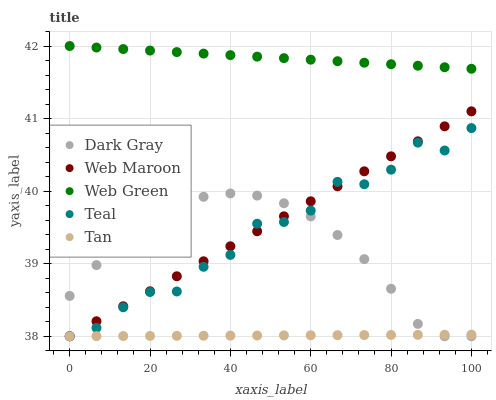Does Tan have the minimum area under the curve?
Answer yes or no. Yes. Does Web Green have the maximum area under the curve?
Answer yes or no. Yes. Does Web Maroon have the minimum area under the curve?
Answer yes or no. No. Does Web Maroon have the maximum area under the curve?
Answer yes or no. No. Is Tan the smoothest?
Answer yes or no. Yes. Is Teal the roughest?
Answer yes or no. Yes. Is Web Maroon the smoothest?
Answer yes or no. No. Is Web Maroon the roughest?
Answer yes or no. No. Does Dark Gray have the lowest value?
Answer yes or no. Yes. Does Web Green have the lowest value?
Answer yes or no. No. Does Web Green have the highest value?
Answer yes or no. Yes. Does Web Maroon have the highest value?
Answer yes or no. No. Is Teal less than Web Green?
Answer yes or no. Yes. Is Web Green greater than Teal?
Answer yes or no. Yes. Does Tan intersect Web Maroon?
Answer yes or no. Yes. Is Tan less than Web Maroon?
Answer yes or no. No. Is Tan greater than Web Maroon?
Answer yes or no. No. Does Teal intersect Web Green?
Answer yes or no. No. 